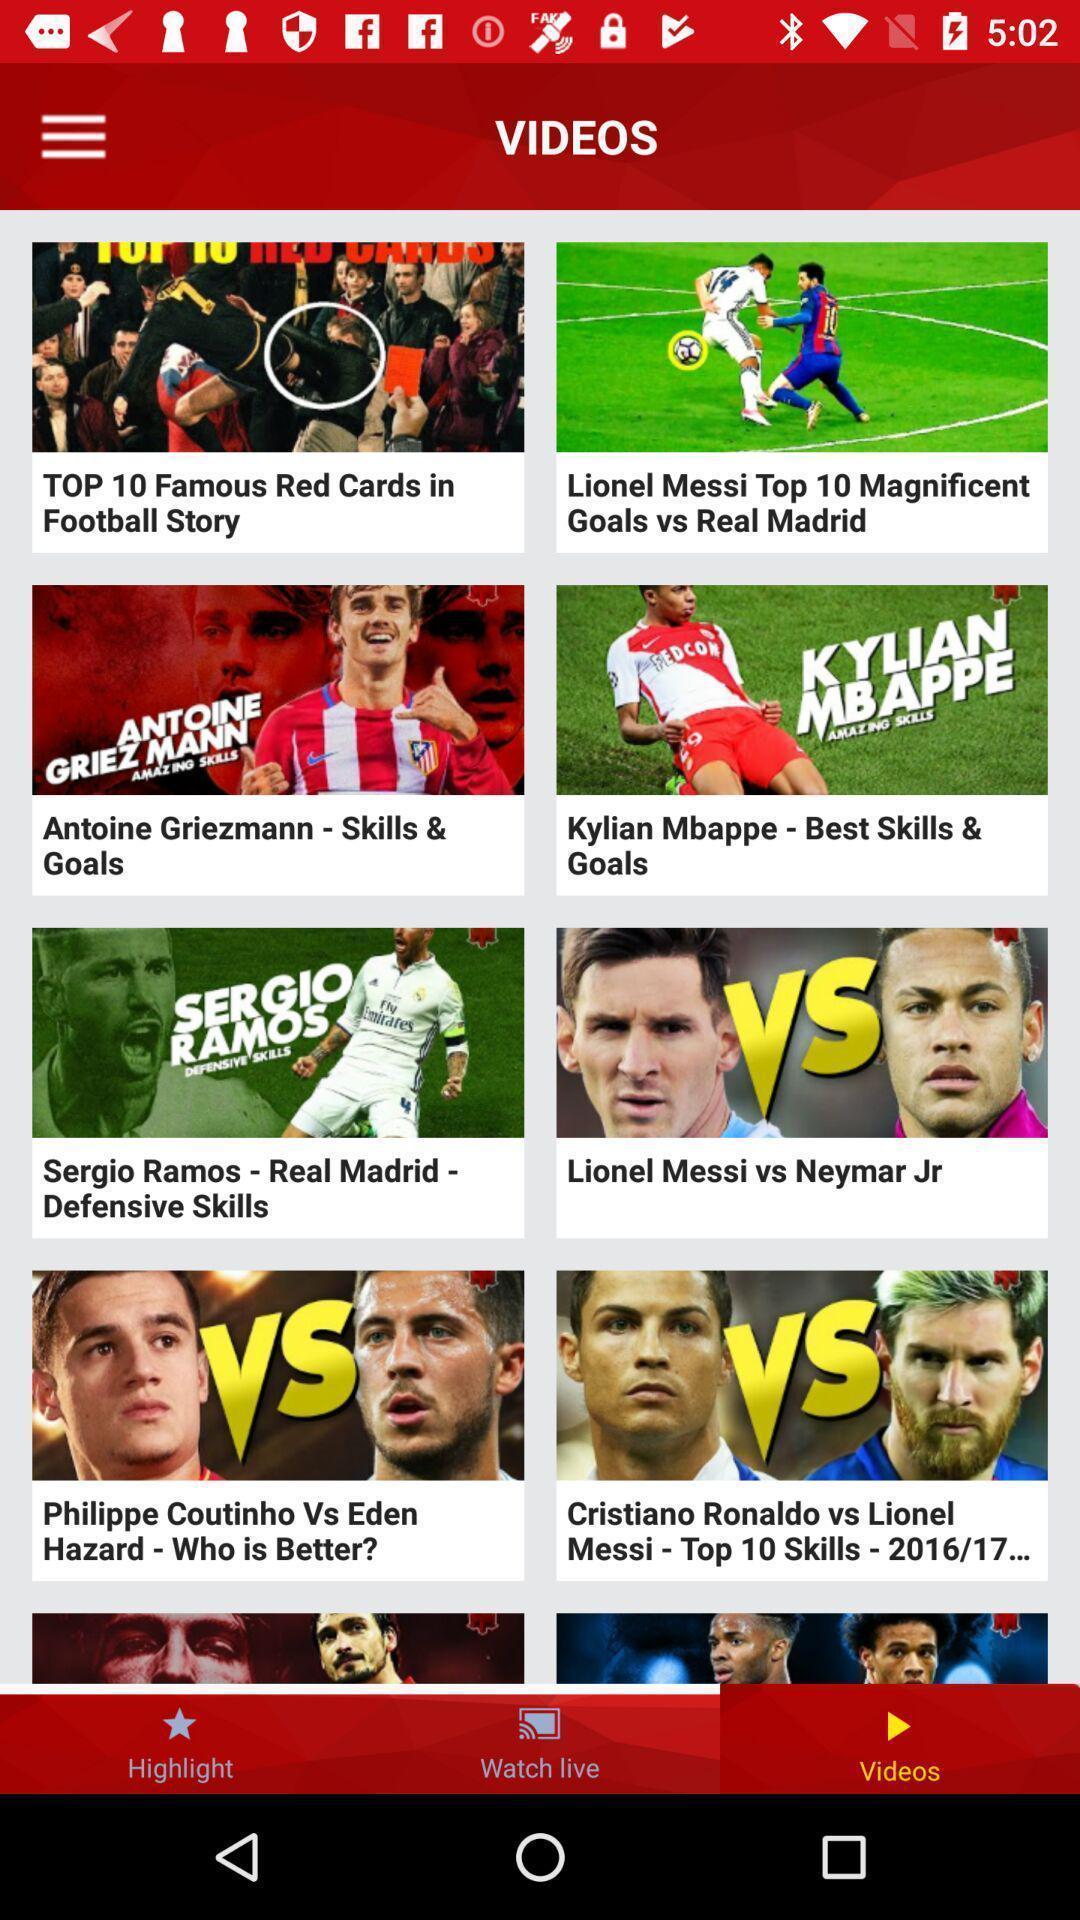Tell me about the visual elements in this screen capture. Page showing different videos on an app. 